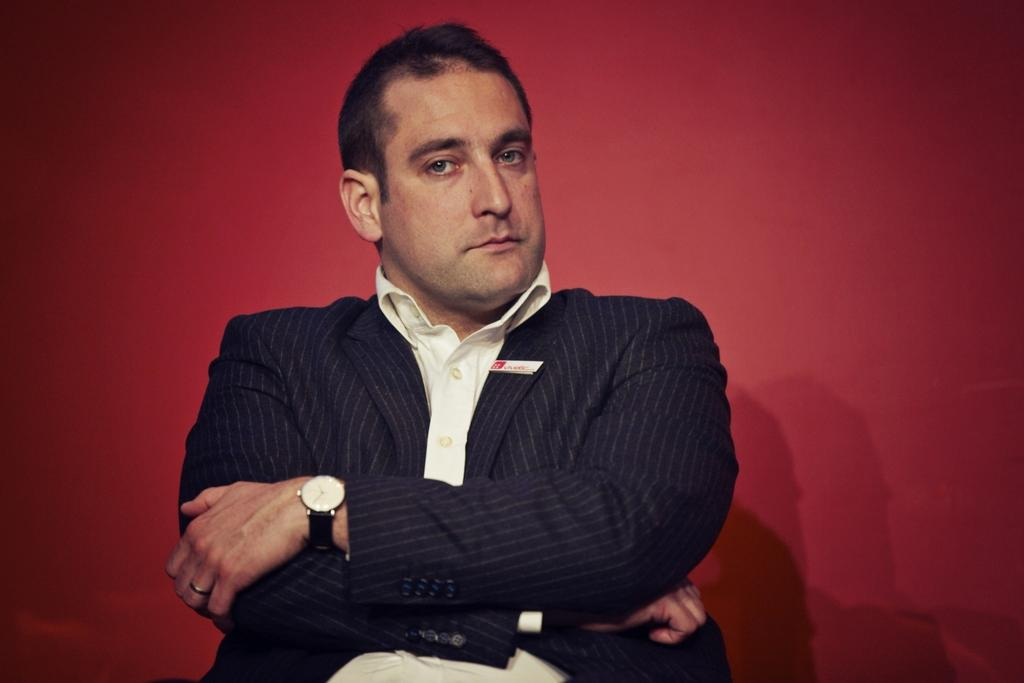Who is the main subject in the image? There is a man in the image. What is the man wearing? The man is wearing a suit. Where is the man located in the image? The man is sitting in the middle of the image. What is attached to the man's suit? There is a batch attached to the man's suit. What color is the background of the image? The background of the image is red. What type of cup is being used in the process shown in the image? There is no cup or process visible in the image; it features a man sitting with a batch attached to his suit against a red background. 